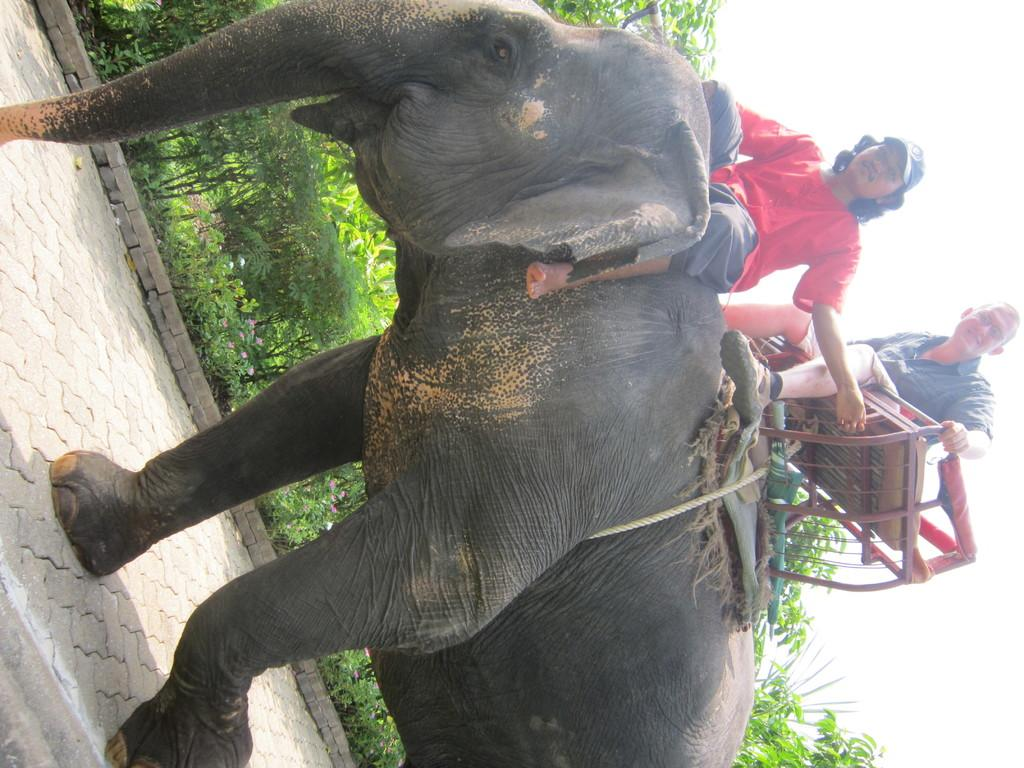How many people are in the image? There are two people in the image. What colors are the shirts of the two people? One person is wearing a red shirt, and the other person is wearing a black shirt. What are the two people doing in the image? The two people are sitting on an elephant. What can be seen in the background of the image? There are plants and trees around in the image. What type of van can be seen parked near the elephant in the image? There is no van present in the image; it features two people sitting on an elephant with plants and trees in the background. 